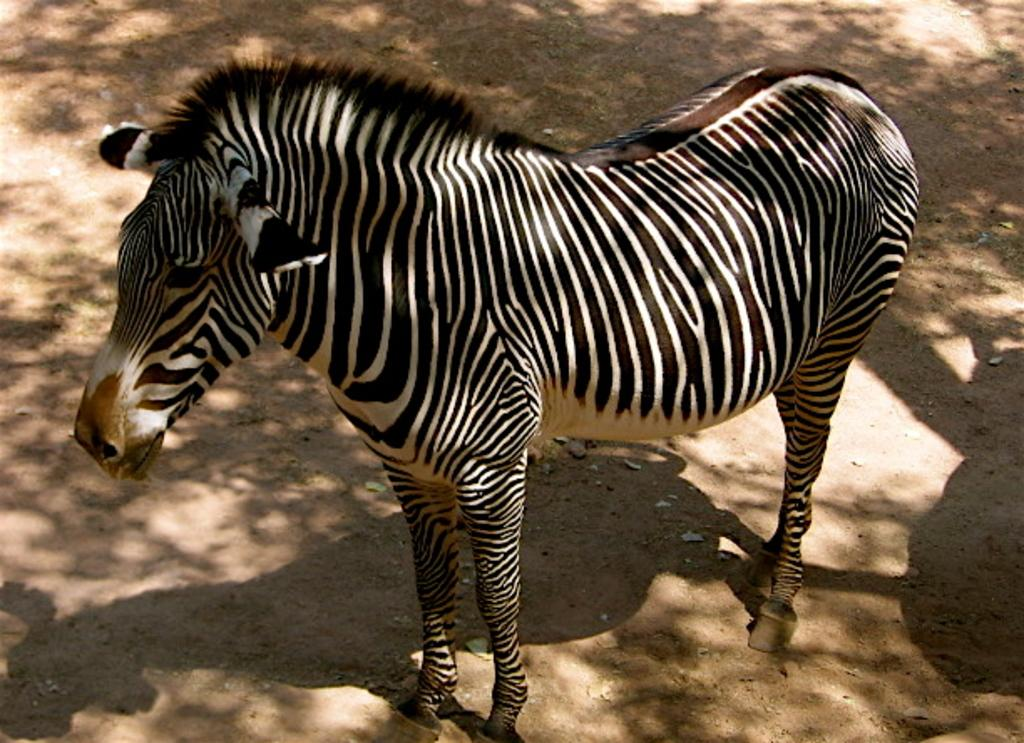What animal is the main subject of the image? There is a zebra in the image. Where is the zebra located in the image? The zebra is standing in the center of the image. What is the zebra's position relative to the ground in the image? The zebra is on the ground in the image. What type of chess piece is the zebra in the image? The image does not depict a chessboard or any chess pieces; it features a zebra standing on the ground. What holiday is being celebrated in the image? There is no indication of a holiday being celebrated in the image; it simply shows a zebra standing on the ground. 